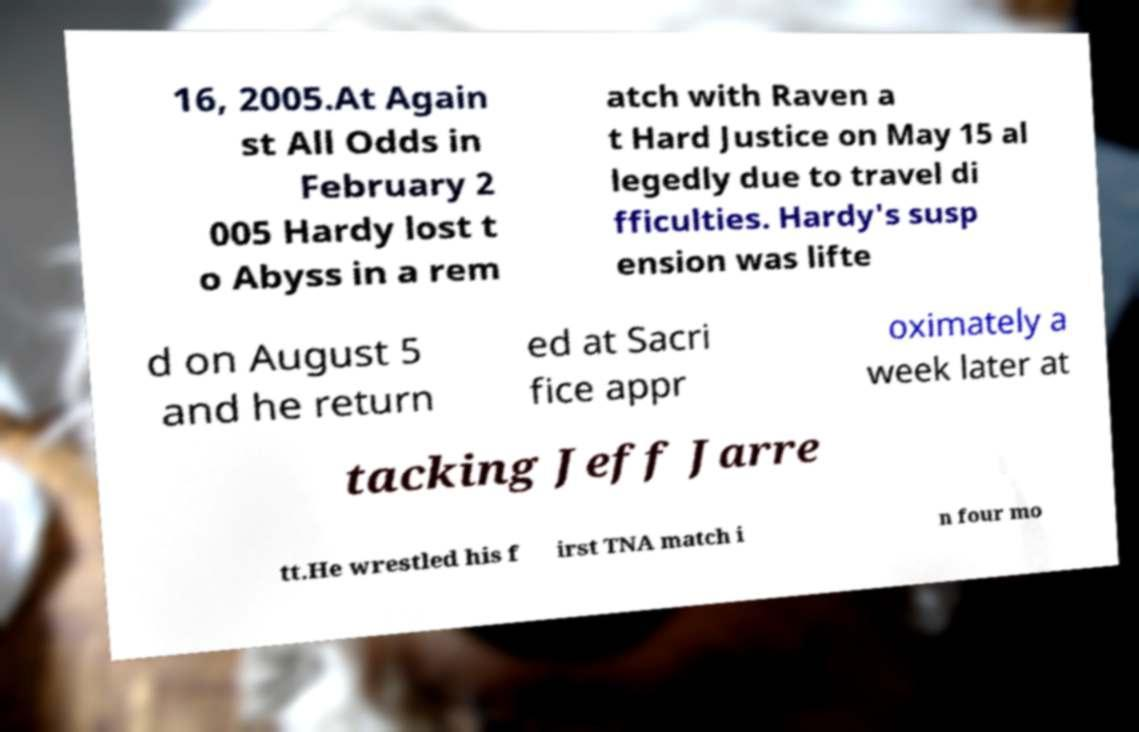There's text embedded in this image that I need extracted. Can you transcribe it verbatim? 16, 2005.At Again st All Odds in February 2 005 Hardy lost t o Abyss in a rem atch with Raven a t Hard Justice on May 15 al legedly due to travel di fficulties. Hardy's susp ension was lifte d on August 5 and he return ed at Sacri fice appr oximately a week later at tacking Jeff Jarre tt.He wrestled his f irst TNA match i n four mo 